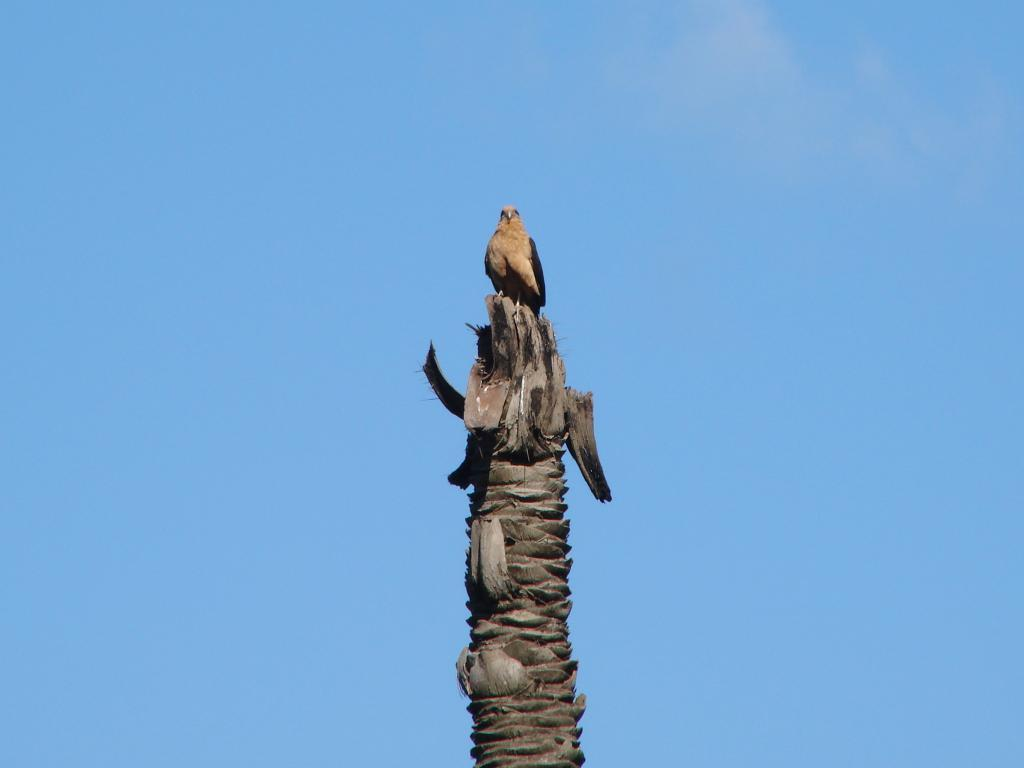What type of animal can be seen in the image? There is a bird in the image. Where is the bird located? The bird is on the trunk of a tree. What can be seen in the background of the image? The background of the image is the sky. What type of punishment is the bird receiving in the image? There is no punishment being administered to the bird in the image; it is simply perched on the trunk of a tree. 